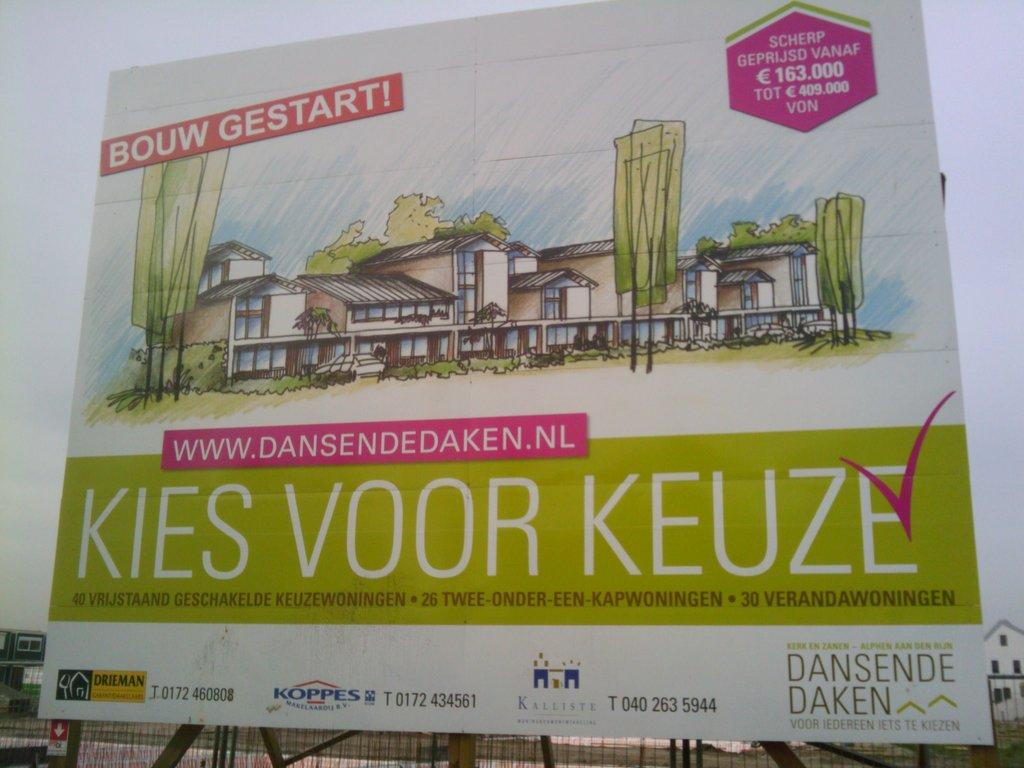<image>
Create a compact narrative representing the image presented. A building is developed by a company named Dansende Daken. 